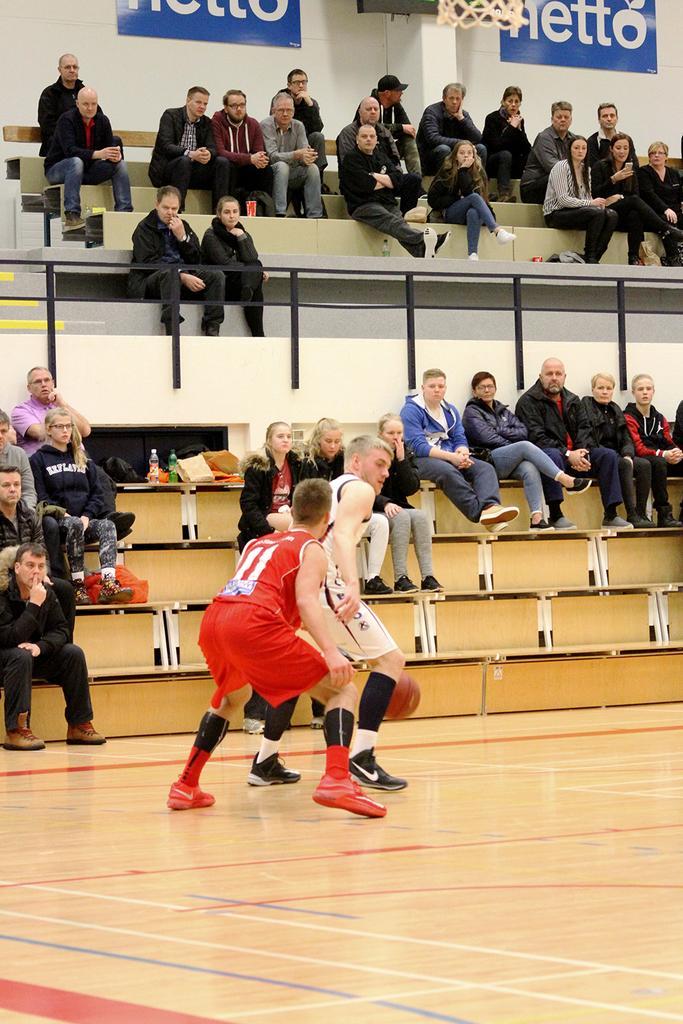Please provide a concise description of this image. In front of the picture, we see a man in the red T-shirt and the man in the white T-shirt are playing the basketball. In front of them, we see a basketball. Beside them, we see the people are sitting on the stairs. We see the water bottles and books are placed on the stairs. At the top, we see the people sitting on the staircase. Behind them, we see a wall on which blue boards are placed. We see some text written on the boards. We see a basketball hoop. 